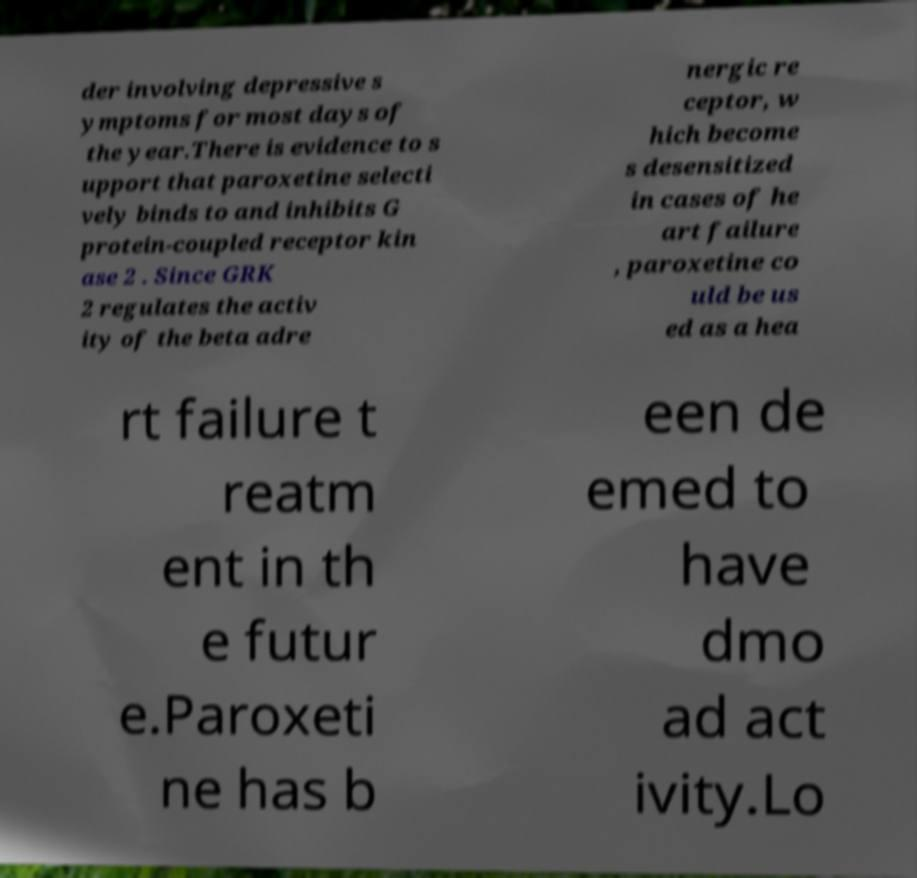There's text embedded in this image that I need extracted. Can you transcribe it verbatim? der involving depressive s ymptoms for most days of the year.There is evidence to s upport that paroxetine selecti vely binds to and inhibits G protein-coupled receptor kin ase 2 . Since GRK 2 regulates the activ ity of the beta adre nergic re ceptor, w hich become s desensitized in cases of he art failure , paroxetine co uld be us ed as a hea rt failure t reatm ent in th e futur e.Paroxeti ne has b een de emed to have dmo ad act ivity.Lo 